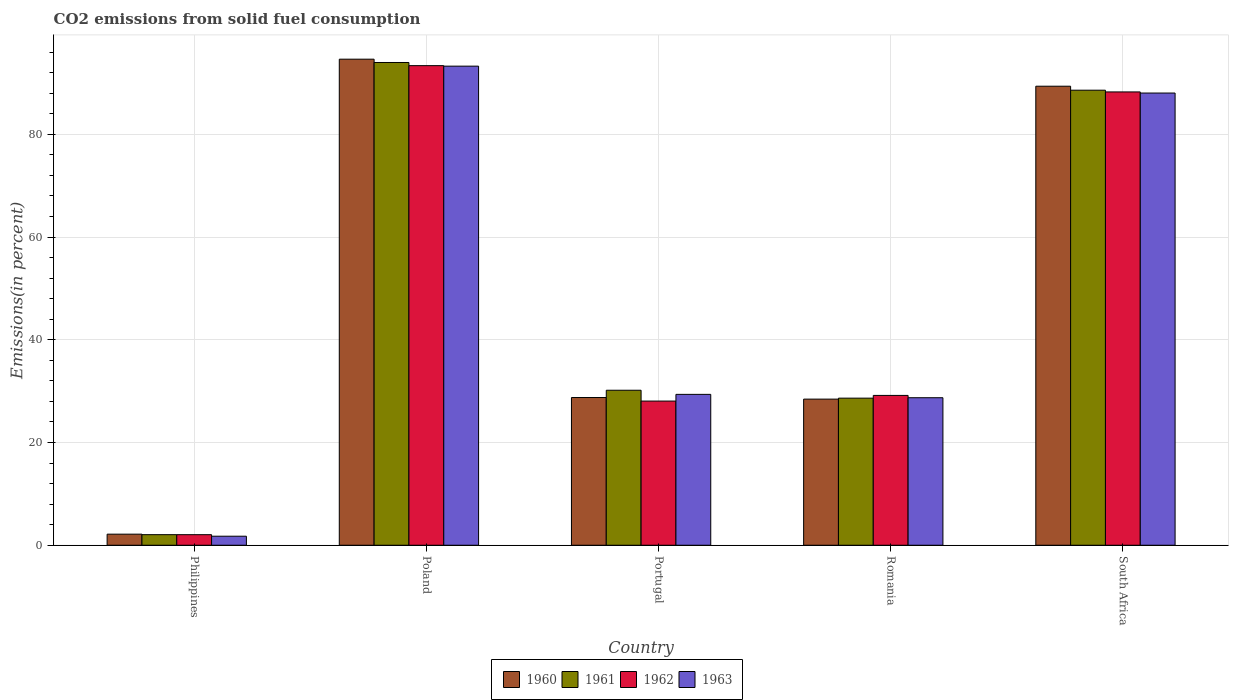How many different coloured bars are there?
Give a very brief answer. 4. How many groups of bars are there?
Keep it short and to the point. 5. Are the number of bars on each tick of the X-axis equal?
Ensure brevity in your answer.  Yes. How many bars are there on the 4th tick from the left?
Provide a short and direct response. 4. How many bars are there on the 5th tick from the right?
Offer a very short reply. 4. In how many cases, is the number of bars for a given country not equal to the number of legend labels?
Give a very brief answer. 0. What is the total CO2 emitted in 1960 in Portugal?
Your response must be concise. 28.76. Across all countries, what is the maximum total CO2 emitted in 1960?
Make the answer very short. 94.62. Across all countries, what is the minimum total CO2 emitted in 1961?
Give a very brief answer. 2.06. In which country was the total CO2 emitted in 1960 maximum?
Ensure brevity in your answer.  Poland. What is the total total CO2 emitted in 1960 in the graph?
Your answer should be compact. 243.34. What is the difference between the total CO2 emitted in 1961 in Portugal and that in Romania?
Keep it short and to the point. 1.54. What is the difference between the total CO2 emitted in 1961 in Portugal and the total CO2 emitted in 1962 in South Africa?
Your response must be concise. -58.07. What is the average total CO2 emitted in 1963 per country?
Provide a succinct answer. 48.23. What is the difference between the total CO2 emitted of/in 1960 and total CO2 emitted of/in 1963 in South Africa?
Provide a short and direct response. 1.33. In how many countries, is the total CO2 emitted in 1963 greater than 64 %?
Make the answer very short. 2. What is the ratio of the total CO2 emitted in 1963 in Poland to that in South Africa?
Keep it short and to the point. 1.06. What is the difference between the highest and the second highest total CO2 emitted in 1962?
Keep it short and to the point. 59.08. What is the difference between the highest and the lowest total CO2 emitted in 1963?
Offer a terse response. 91.51. In how many countries, is the total CO2 emitted in 1960 greater than the average total CO2 emitted in 1960 taken over all countries?
Offer a very short reply. 2. Is the sum of the total CO2 emitted in 1963 in Poland and Portugal greater than the maximum total CO2 emitted in 1961 across all countries?
Your answer should be compact. Yes. Is it the case that in every country, the sum of the total CO2 emitted in 1963 and total CO2 emitted in 1960 is greater than the total CO2 emitted in 1962?
Provide a succinct answer. Yes. How many countries are there in the graph?
Offer a terse response. 5. Are the values on the major ticks of Y-axis written in scientific E-notation?
Offer a terse response. No. Does the graph contain grids?
Your response must be concise. Yes. Where does the legend appear in the graph?
Ensure brevity in your answer.  Bottom center. How many legend labels are there?
Ensure brevity in your answer.  4. What is the title of the graph?
Offer a very short reply. CO2 emissions from solid fuel consumption. What is the label or title of the Y-axis?
Provide a succinct answer. Emissions(in percent). What is the Emissions(in percent) of 1960 in Philippines?
Provide a short and direct response. 2.16. What is the Emissions(in percent) in 1961 in Philippines?
Provide a succinct answer. 2.06. What is the Emissions(in percent) of 1962 in Philippines?
Your answer should be very brief. 2.06. What is the Emissions(in percent) in 1963 in Philippines?
Ensure brevity in your answer.  1.76. What is the Emissions(in percent) in 1960 in Poland?
Give a very brief answer. 94.62. What is the Emissions(in percent) in 1961 in Poland?
Ensure brevity in your answer.  93.98. What is the Emissions(in percent) of 1962 in Poland?
Provide a short and direct response. 93.36. What is the Emissions(in percent) in 1963 in Poland?
Your answer should be very brief. 93.27. What is the Emissions(in percent) of 1960 in Portugal?
Provide a short and direct response. 28.76. What is the Emissions(in percent) of 1961 in Portugal?
Your answer should be compact. 30.17. What is the Emissions(in percent) of 1962 in Portugal?
Your response must be concise. 28.06. What is the Emissions(in percent) of 1963 in Portugal?
Give a very brief answer. 29.37. What is the Emissions(in percent) of 1960 in Romania?
Keep it short and to the point. 28.44. What is the Emissions(in percent) in 1961 in Romania?
Make the answer very short. 28.63. What is the Emissions(in percent) in 1962 in Romania?
Give a very brief answer. 29.17. What is the Emissions(in percent) in 1963 in Romania?
Your answer should be compact. 28.72. What is the Emissions(in percent) of 1960 in South Africa?
Give a very brief answer. 89.36. What is the Emissions(in percent) of 1961 in South Africa?
Offer a terse response. 88.58. What is the Emissions(in percent) in 1962 in South Africa?
Provide a short and direct response. 88.25. What is the Emissions(in percent) of 1963 in South Africa?
Provide a short and direct response. 88.03. Across all countries, what is the maximum Emissions(in percent) in 1960?
Ensure brevity in your answer.  94.62. Across all countries, what is the maximum Emissions(in percent) in 1961?
Offer a terse response. 93.98. Across all countries, what is the maximum Emissions(in percent) in 1962?
Offer a very short reply. 93.36. Across all countries, what is the maximum Emissions(in percent) in 1963?
Offer a very short reply. 93.27. Across all countries, what is the minimum Emissions(in percent) in 1960?
Provide a short and direct response. 2.16. Across all countries, what is the minimum Emissions(in percent) in 1961?
Your answer should be compact. 2.06. Across all countries, what is the minimum Emissions(in percent) of 1962?
Give a very brief answer. 2.06. Across all countries, what is the minimum Emissions(in percent) in 1963?
Offer a very short reply. 1.76. What is the total Emissions(in percent) of 1960 in the graph?
Ensure brevity in your answer.  243.34. What is the total Emissions(in percent) of 1961 in the graph?
Offer a terse response. 243.43. What is the total Emissions(in percent) in 1962 in the graph?
Keep it short and to the point. 240.9. What is the total Emissions(in percent) of 1963 in the graph?
Your answer should be compact. 241.14. What is the difference between the Emissions(in percent) of 1960 in Philippines and that in Poland?
Provide a short and direct response. -92.47. What is the difference between the Emissions(in percent) in 1961 in Philippines and that in Poland?
Ensure brevity in your answer.  -91.92. What is the difference between the Emissions(in percent) of 1962 in Philippines and that in Poland?
Keep it short and to the point. -91.31. What is the difference between the Emissions(in percent) of 1963 in Philippines and that in Poland?
Your answer should be compact. -91.51. What is the difference between the Emissions(in percent) of 1960 in Philippines and that in Portugal?
Your answer should be compact. -26.6. What is the difference between the Emissions(in percent) of 1961 in Philippines and that in Portugal?
Make the answer very short. -28.11. What is the difference between the Emissions(in percent) in 1962 in Philippines and that in Portugal?
Your response must be concise. -26.01. What is the difference between the Emissions(in percent) of 1963 in Philippines and that in Portugal?
Make the answer very short. -27.61. What is the difference between the Emissions(in percent) in 1960 in Philippines and that in Romania?
Ensure brevity in your answer.  -26.29. What is the difference between the Emissions(in percent) in 1961 in Philippines and that in Romania?
Give a very brief answer. -26.57. What is the difference between the Emissions(in percent) of 1962 in Philippines and that in Romania?
Your answer should be compact. -27.11. What is the difference between the Emissions(in percent) of 1963 in Philippines and that in Romania?
Provide a short and direct response. -26.96. What is the difference between the Emissions(in percent) of 1960 in Philippines and that in South Africa?
Offer a very short reply. -87.2. What is the difference between the Emissions(in percent) of 1961 in Philippines and that in South Africa?
Give a very brief answer. -86.52. What is the difference between the Emissions(in percent) of 1962 in Philippines and that in South Africa?
Your answer should be compact. -86.19. What is the difference between the Emissions(in percent) of 1963 in Philippines and that in South Africa?
Your answer should be very brief. -86.27. What is the difference between the Emissions(in percent) of 1960 in Poland and that in Portugal?
Your response must be concise. 65.87. What is the difference between the Emissions(in percent) in 1961 in Poland and that in Portugal?
Make the answer very short. 63.8. What is the difference between the Emissions(in percent) in 1962 in Poland and that in Portugal?
Your answer should be very brief. 65.3. What is the difference between the Emissions(in percent) of 1963 in Poland and that in Portugal?
Your answer should be very brief. 63.9. What is the difference between the Emissions(in percent) of 1960 in Poland and that in Romania?
Your answer should be very brief. 66.18. What is the difference between the Emissions(in percent) in 1961 in Poland and that in Romania?
Provide a succinct answer. 65.34. What is the difference between the Emissions(in percent) of 1962 in Poland and that in Romania?
Give a very brief answer. 64.2. What is the difference between the Emissions(in percent) in 1963 in Poland and that in Romania?
Offer a very short reply. 64.55. What is the difference between the Emissions(in percent) of 1960 in Poland and that in South Africa?
Your answer should be very brief. 5.26. What is the difference between the Emissions(in percent) in 1961 in Poland and that in South Africa?
Provide a short and direct response. 5.39. What is the difference between the Emissions(in percent) of 1962 in Poland and that in South Africa?
Ensure brevity in your answer.  5.12. What is the difference between the Emissions(in percent) of 1963 in Poland and that in South Africa?
Ensure brevity in your answer.  5.24. What is the difference between the Emissions(in percent) in 1960 in Portugal and that in Romania?
Ensure brevity in your answer.  0.31. What is the difference between the Emissions(in percent) in 1961 in Portugal and that in Romania?
Keep it short and to the point. 1.54. What is the difference between the Emissions(in percent) in 1962 in Portugal and that in Romania?
Provide a short and direct response. -1.1. What is the difference between the Emissions(in percent) in 1963 in Portugal and that in Romania?
Provide a short and direct response. 0.65. What is the difference between the Emissions(in percent) of 1960 in Portugal and that in South Africa?
Your answer should be very brief. -60.6. What is the difference between the Emissions(in percent) of 1961 in Portugal and that in South Africa?
Your answer should be very brief. -58.41. What is the difference between the Emissions(in percent) of 1962 in Portugal and that in South Africa?
Ensure brevity in your answer.  -60.18. What is the difference between the Emissions(in percent) in 1963 in Portugal and that in South Africa?
Make the answer very short. -58.66. What is the difference between the Emissions(in percent) of 1960 in Romania and that in South Africa?
Your response must be concise. -60.91. What is the difference between the Emissions(in percent) of 1961 in Romania and that in South Africa?
Make the answer very short. -59.95. What is the difference between the Emissions(in percent) in 1962 in Romania and that in South Africa?
Your response must be concise. -59.08. What is the difference between the Emissions(in percent) in 1963 in Romania and that in South Africa?
Offer a very short reply. -59.31. What is the difference between the Emissions(in percent) in 1960 in Philippines and the Emissions(in percent) in 1961 in Poland?
Make the answer very short. -91.82. What is the difference between the Emissions(in percent) in 1960 in Philippines and the Emissions(in percent) in 1962 in Poland?
Keep it short and to the point. -91.21. What is the difference between the Emissions(in percent) of 1960 in Philippines and the Emissions(in percent) of 1963 in Poland?
Keep it short and to the point. -91.11. What is the difference between the Emissions(in percent) in 1961 in Philippines and the Emissions(in percent) in 1962 in Poland?
Offer a very short reply. -91.3. What is the difference between the Emissions(in percent) in 1961 in Philippines and the Emissions(in percent) in 1963 in Poland?
Your response must be concise. -91.21. What is the difference between the Emissions(in percent) of 1962 in Philippines and the Emissions(in percent) of 1963 in Poland?
Offer a very short reply. -91.21. What is the difference between the Emissions(in percent) in 1960 in Philippines and the Emissions(in percent) in 1961 in Portugal?
Offer a very short reply. -28.02. What is the difference between the Emissions(in percent) in 1960 in Philippines and the Emissions(in percent) in 1962 in Portugal?
Keep it short and to the point. -25.91. What is the difference between the Emissions(in percent) of 1960 in Philippines and the Emissions(in percent) of 1963 in Portugal?
Make the answer very short. -27.22. What is the difference between the Emissions(in percent) of 1961 in Philippines and the Emissions(in percent) of 1962 in Portugal?
Provide a short and direct response. -26. What is the difference between the Emissions(in percent) of 1961 in Philippines and the Emissions(in percent) of 1963 in Portugal?
Offer a very short reply. -27.31. What is the difference between the Emissions(in percent) in 1962 in Philippines and the Emissions(in percent) in 1963 in Portugal?
Give a very brief answer. -27.32. What is the difference between the Emissions(in percent) in 1960 in Philippines and the Emissions(in percent) in 1961 in Romania?
Provide a succinct answer. -26.48. What is the difference between the Emissions(in percent) of 1960 in Philippines and the Emissions(in percent) of 1962 in Romania?
Provide a short and direct response. -27.01. What is the difference between the Emissions(in percent) of 1960 in Philippines and the Emissions(in percent) of 1963 in Romania?
Your answer should be compact. -26.56. What is the difference between the Emissions(in percent) of 1961 in Philippines and the Emissions(in percent) of 1962 in Romania?
Offer a very short reply. -27.11. What is the difference between the Emissions(in percent) in 1961 in Philippines and the Emissions(in percent) in 1963 in Romania?
Your response must be concise. -26.66. What is the difference between the Emissions(in percent) of 1962 in Philippines and the Emissions(in percent) of 1963 in Romania?
Ensure brevity in your answer.  -26.66. What is the difference between the Emissions(in percent) in 1960 in Philippines and the Emissions(in percent) in 1961 in South Africa?
Your answer should be very brief. -86.43. What is the difference between the Emissions(in percent) in 1960 in Philippines and the Emissions(in percent) in 1962 in South Africa?
Give a very brief answer. -86.09. What is the difference between the Emissions(in percent) of 1960 in Philippines and the Emissions(in percent) of 1963 in South Africa?
Provide a short and direct response. -85.87. What is the difference between the Emissions(in percent) of 1961 in Philippines and the Emissions(in percent) of 1962 in South Africa?
Offer a very short reply. -86.19. What is the difference between the Emissions(in percent) in 1961 in Philippines and the Emissions(in percent) in 1963 in South Africa?
Your answer should be compact. -85.97. What is the difference between the Emissions(in percent) of 1962 in Philippines and the Emissions(in percent) of 1963 in South Africa?
Your answer should be very brief. -85.97. What is the difference between the Emissions(in percent) of 1960 in Poland and the Emissions(in percent) of 1961 in Portugal?
Offer a very short reply. 64.45. What is the difference between the Emissions(in percent) in 1960 in Poland and the Emissions(in percent) in 1962 in Portugal?
Give a very brief answer. 66.56. What is the difference between the Emissions(in percent) of 1960 in Poland and the Emissions(in percent) of 1963 in Portugal?
Provide a succinct answer. 65.25. What is the difference between the Emissions(in percent) in 1961 in Poland and the Emissions(in percent) in 1962 in Portugal?
Give a very brief answer. 65.91. What is the difference between the Emissions(in percent) in 1961 in Poland and the Emissions(in percent) in 1963 in Portugal?
Make the answer very short. 64.61. What is the difference between the Emissions(in percent) of 1962 in Poland and the Emissions(in percent) of 1963 in Portugal?
Your answer should be very brief. 63.99. What is the difference between the Emissions(in percent) in 1960 in Poland and the Emissions(in percent) in 1961 in Romania?
Give a very brief answer. 65.99. What is the difference between the Emissions(in percent) of 1960 in Poland and the Emissions(in percent) of 1962 in Romania?
Provide a short and direct response. 65.45. What is the difference between the Emissions(in percent) of 1960 in Poland and the Emissions(in percent) of 1963 in Romania?
Offer a terse response. 65.9. What is the difference between the Emissions(in percent) of 1961 in Poland and the Emissions(in percent) of 1962 in Romania?
Keep it short and to the point. 64.81. What is the difference between the Emissions(in percent) in 1961 in Poland and the Emissions(in percent) in 1963 in Romania?
Offer a terse response. 65.26. What is the difference between the Emissions(in percent) of 1962 in Poland and the Emissions(in percent) of 1963 in Romania?
Your response must be concise. 64.65. What is the difference between the Emissions(in percent) of 1960 in Poland and the Emissions(in percent) of 1961 in South Africa?
Ensure brevity in your answer.  6.04. What is the difference between the Emissions(in percent) of 1960 in Poland and the Emissions(in percent) of 1962 in South Africa?
Give a very brief answer. 6.37. What is the difference between the Emissions(in percent) of 1960 in Poland and the Emissions(in percent) of 1963 in South Africa?
Ensure brevity in your answer.  6.59. What is the difference between the Emissions(in percent) in 1961 in Poland and the Emissions(in percent) in 1962 in South Africa?
Keep it short and to the point. 5.73. What is the difference between the Emissions(in percent) in 1961 in Poland and the Emissions(in percent) in 1963 in South Africa?
Ensure brevity in your answer.  5.95. What is the difference between the Emissions(in percent) of 1962 in Poland and the Emissions(in percent) of 1963 in South Africa?
Your response must be concise. 5.33. What is the difference between the Emissions(in percent) of 1960 in Portugal and the Emissions(in percent) of 1961 in Romania?
Give a very brief answer. 0.12. What is the difference between the Emissions(in percent) of 1960 in Portugal and the Emissions(in percent) of 1962 in Romania?
Provide a succinct answer. -0.41. What is the difference between the Emissions(in percent) in 1960 in Portugal and the Emissions(in percent) in 1963 in Romania?
Ensure brevity in your answer.  0.04. What is the difference between the Emissions(in percent) of 1961 in Portugal and the Emissions(in percent) of 1963 in Romania?
Make the answer very short. 1.46. What is the difference between the Emissions(in percent) of 1962 in Portugal and the Emissions(in percent) of 1963 in Romania?
Your answer should be compact. -0.65. What is the difference between the Emissions(in percent) of 1960 in Portugal and the Emissions(in percent) of 1961 in South Africa?
Offer a terse response. -59.83. What is the difference between the Emissions(in percent) of 1960 in Portugal and the Emissions(in percent) of 1962 in South Africa?
Provide a succinct answer. -59.49. What is the difference between the Emissions(in percent) of 1960 in Portugal and the Emissions(in percent) of 1963 in South Africa?
Provide a short and direct response. -59.27. What is the difference between the Emissions(in percent) of 1961 in Portugal and the Emissions(in percent) of 1962 in South Africa?
Your answer should be compact. -58.07. What is the difference between the Emissions(in percent) in 1961 in Portugal and the Emissions(in percent) in 1963 in South Africa?
Give a very brief answer. -57.86. What is the difference between the Emissions(in percent) in 1962 in Portugal and the Emissions(in percent) in 1963 in South Africa?
Give a very brief answer. -59.97. What is the difference between the Emissions(in percent) of 1960 in Romania and the Emissions(in percent) of 1961 in South Africa?
Keep it short and to the point. -60.14. What is the difference between the Emissions(in percent) of 1960 in Romania and the Emissions(in percent) of 1962 in South Africa?
Provide a succinct answer. -59.8. What is the difference between the Emissions(in percent) in 1960 in Romania and the Emissions(in percent) in 1963 in South Africa?
Provide a succinct answer. -59.59. What is the difference between the Emissions(in percent) of 1961 in Romania and the Emissions(in percent) of 1962 in South Africa?
Your response must be concise. -59.61. What is the difference between the Emissions(in percent) in 1961 in Romania and the Emissions(in percent) in 1963 in South Africa?
Provide a short and direct response. -59.4. What is the difference between the Emissions(in percent) of 1962 in Romania and the Emissions(in percent) of 1963 in South Africa?
Keep it short and to the point. -58.86. What is the average Emissions(in percent) in 1960 per country?
Provide a succinct answer. 48.67. What is the average Emissions(in percent) of 1961 per country?
Your answer should be very brief. 48.69. What is the average Emissions(in percent) of 1962 per country?
Your response must be concise. 48.18. What is the average Emissions(in percent) in 1963 per country?
Ensure brevity in your answer.  48.23. What is the difference between the Emissions(in percent) in 1960 and Emissions(in percent) in 1961 in Philippines?
Your response must be concise. 0.1. What is the difference between the Emissions(in percent) in 1960 and Emissions(in percent) in 1962 in Philippines?
Make the answer very short. 0.1. What is the difference between the Emissions(in percent) in 1960 and Emissions(in percent) in 1963 in Philippines?
Your response must be concise. 0.4. What is the difference between the Emissions(in percent) of 1961 and Emissions(in percent) of 1962 in Philippines?
Offer a terse response. 0. What is the difference between the Emissions(in percent) in 1961 and Emissions(in percent) in 1963 in Philippines?
Give a very brief answer. 0.3. What is the difference between the Emissions(in percent) of 1962 and Emissions(in percent) of 1963 in Philippines?
Ensure brevity in your answer.  0.3. What is the difference between the Emissions(in percent) in 1960 and Emissions(in percent) in 1961 in Poland?
Your response must be concise. 0.64. What is the difference between the Emissions(in percent) of 1960 and Emissions(in percent) of 1962 in Poland?
Ensure brevity in your answer.  1.26. What is the difference between the Emissions(in percent) of 1960 and Emissions(in percent) of 1963 in Poland?
Keep it short and to the point. 1.36. What is the difference between the Emissions(in percent) in 1961 and Emissions(in percent) in 1962 in Poland?
Keep it short and to the point. 0.61. What is the difference between the Emissions(in percent) in 1961 and Emissions(in percent) in 1963 in Poland?
Offer a terse response. 0.71. What is the difference between the Emissions(in percent) in 1962 and Emissions(in percent) in 1963 in Poland?
Your response must be concise. 0.1. What is the difference between the Emissions(in percent) of 1960 and Emissions(in percent) of 1961 in Portugal?
Your answer should be compact. -1.42. What is the difference between the Emissions(in percent) in 1960 and Emissions(in percent) in 1962 in Portugal?
Your answer should be very brief. 0.69. What is the difference between the Emissions(in percent) in 1960 and Emissions(in percent) in 1963 in Portugal?
Make the answer very short. -0.61. What is the difference between the Emissions(in percent) in 1961 and Emissions(in percent) in 1962 in Portugal?
Offer a very short reply. 2.11. What is the difference between the Emissions(in percent) in 1961 and Emissions(in percent) in 1963 in Portugal?
Your response must be concise. 0.8. What is the difference between the Emissions(in percent) of 1962 and Emissions(in percent) of 1963 in Portugal?
Give a very brief answer. -1.31. What is the difference between the Emissions(in percent) in 1960 and Emissions(in percent) in 1961 in Romania?
Your answer should be compact. -0.19. What is the difference between the Emissions(in percent) in 1960 and Emissions(in percent) in 1962 in Romania?
Ensure brevity in your answer.  -0.72. What is the difference between the Emissions(in percent) in 1960 and Emissions(in percent) in 1963 in Romania?
Your answer should be compact. -0.27. What is the difference between the Emissions(in percent) in 1961 and Emissions(in percent) in 1962 in Romania?
Make the answer very short. -0.54. What is the difference between the Emissions(in percent) of 1961 and Emissions(in percent) of 1963 in Romania?
Keep it short and to the point. -0.08. What is the difference between the Emissions(in percent) in 1962 and Emissions(in percent) in 1963 in Romania?
Make the answer very short. 0.45. What is the difference between the Emissions(in percent) in 1960 and Emissions(in percent) in 1961 in South Africa?
Make the answer very short. 0.77. What is the difference between the Emissions(in percent) of 1960 and Emissions(in percent) of 1962 in South Africa?
Your answer should be very brief. 1.11. What is the difference between the Emissions(in percent) of 1960 and Emissions(in percent) of 1963 in South Africa?
Your response must be concise. 1.33. What is the difference between the Emissions(in percent) of 1961 and Emissions(in percent) of 1962 in South Africa?
Make the answer very short. 0.34. What is the difference between the Emissions(in percent) in 1961 and Emissions(in percent) in 1963 in South Africa?
Ensure brevity in your answer.  0.55. What is the difference between the Emissions(in percent) in 1962 and Emissions(in percent) in 1963 in South Africa?
Provide a succinct answer. 0.22. What is the ratio of the Emissions(in percent) of 1960 in Philippines to that in Poland?
Provide a short and direct response. 0.02. What is the ratio of the Emissions(in percent) in 1961 in Philippines to that in Poland?
Give a very brief answer. 0.02. What is the ratio of the Emissions(in percent) of 1962 in Philippines to that in Poland?
Make the answer very short. 0.02. What is the ratio of the Emissions(in percent) in 1963 in Philippines to that in Poland?
Your response must be concise. 0.02. What is the ratio of the Emissions(in percent) of 1960 in Philippines to that in Portugal?
Your answer should be very brief. 0.07. What is the ratio of the Emissions(in percent) in 1961 in Philippines to that in Portugal?
Ensure brevity in your answer.  0.07. What is the ratio of the Emissions(in percent) in 1962 in Philippines to that in Portugal?
Ensure brevity in your answer.  0.07. What is the ratio of the Emissions(in percent) in 1963 in Philippines to that in Portugal?
Your answer should be compact. 0.06. What is the ratio of the Emissions(in percent) in 1960 in Philippines to that in Romania?
Keep it short and to the point. 0.08. What is the ratio of the Emissions(in percent) in 1961 in Philippines to that in Romania?
Your answer should be very brief. 0.07. What is the ratio of the Emissions(in percent) in 1962 in Philippines to that in Romania?
Make the answer very short. 0.07. What is the ratio of the Emissions(in percent) of 1963 in Philippines to that in Romania?
Keep it short and to the point. 0.06. What is the ratio of the Emissions(in percent) of 1960 in Philippines to that in South Africa?
Provide a short and direct response. 0.02. What is the ratio of the Emissions(in percent) in 1961 in Philippines to that in South Africa?
Give a very brief answer. 0.02. What is the ratio of the Emissions(in percent) of 1962 in Philippines to that in South Africa?
Offer a terse response. 0.02. What is the ratio of the Emissions(in percent) in 1963 in Philippines to that in South Africa?
Ensure brevity in your answer.  0.02. What is the ratio of the Emissions(in percent) in 1960 in Poland to that in Portugal?
Keep it short and to the point. 3.29. What is the ratio of the Emissions(in percent) of 1961 in Poland to that in Portugal?
Your answer should be very brief. 3.11. What is the ratio of the Emissions(in percent) in 1962 in Poland to that in Portugal?
Make the answer very short. 3.33. What is the ratio of the Emissions(in percent) of 1963 in Poland to that in Portugal?
Ensure brevity in your answer.  3.18. What is the ratio of the Emissions(in percent) of 1960 in Poland to that in Romania?
Your response must be concise. 3.33. What is the ratio of the Emissions(in percent) of 1961 in Poland to that in Romania?
Your answer should be compact. 3.28. What is the ratio of the Emissions(in percent) in 1962 in Poland to that in Romania?
Provide a short and direct response. 3.2. What is the ratio of the Emissions(in percent) of 1963 in Poland to that in Romania?
Ensure brevity in your answer.  3.25. What is the ratio of the Emissions(in percent) of 1960 in Poland to that in South Africa?
Keep it short and to the point. 1.06. What is the ratio of the Emissions(in percent) in 1961 in Poland to that in South Africa?
Offer a very short reply. 1.06. What is the ratio of the Emissions(in percent) of 1962 in Poland to that in South Africa?
Offer a terse response. 1.06. What is the ratio of the Emissions(in percent) of 1963 in Poland to that in South Africa?
Keep it short and to the point. 1.06. What is the ratio of the Emissions(in percent) of 1960 in Portugal to that in Romania?
Give a very brief answer. 1.01. What is the ratio of the Emissions(in percent) of 1961 in Portugal to that in Romania?
Your response must be concise. 1.05. What is the ratio of the Emissions(in percent) in 1962 in Portugal to that in Romania?
Provide a short and direct response. 0.96. What is the ratio of the Emissions(in percent) of 1963 in Portugal to that in Romania?
Make the answer very short. 1.02. What is the ratio of the Emissions(in percent) of 1960 in Portugal to that in South Africa?
Offer a terse response. 0.32. What is the ratio of the Emissions(in percent) of 1961 in Portugal to that in South Africa?
Offer a terse response. 0.34. What is the ratio of the Emissions(in percent) in 1962 in Portugal to that in South Africa?
Your response must be concise. 0.32. What is the ratio of the Emissions(in percent) in 1963 in Portugal to that in South Africa?
Keep it short and to the point. 0.33. What is the ratio of the Emissions(in percent) of 1960 in Romania to that in South Africa?
Provide a short and direct response. 0.32. What is the ratio of the Emissions(in percent) of 1961 in Romania to that in South Africa?
Offer a very short reply. 0.32. What is the ratio of the Emissions(in percent) of 1962 in Romania to that in South Africa?
Keep it short and to the point. 0.33. What is the ratio of the Emissions(in percent) in 1963 in Romania to that in South Africa?
Your response must be concise. 0.33. What is the difference between the highest and the second highest Emissions(in percent) in 1960?
Offer a terse response. 5.26. What is the difference between the highest and the second highest Emissions(in percent) of 1961?
Ensure brevity in your answer.  5.39. What is the difference between the highest and the second highest Emissions(in percent) of 1962?
Offer a terse response. 5.12. What is the difference between the highest and the second highest Emissions(in percent) of 1963?
Your answer should be compact. 5.24. What is the difference between the highest and the lowest Emissions(in percent) in 1960?
Provide a succinct answer. 92.47. What is the difference between the highest and the lowest Emissions(in percent) in 1961?
Give a very brief answer. 91.92. What is the difference between the highest and the lowest Emissions(in percent) in 1962?
Offer a very short reply. 91.31. What is the difference between the highest and the lowest Emissions(in percent) in 1963?
Your answer should be compact. 91.51. 